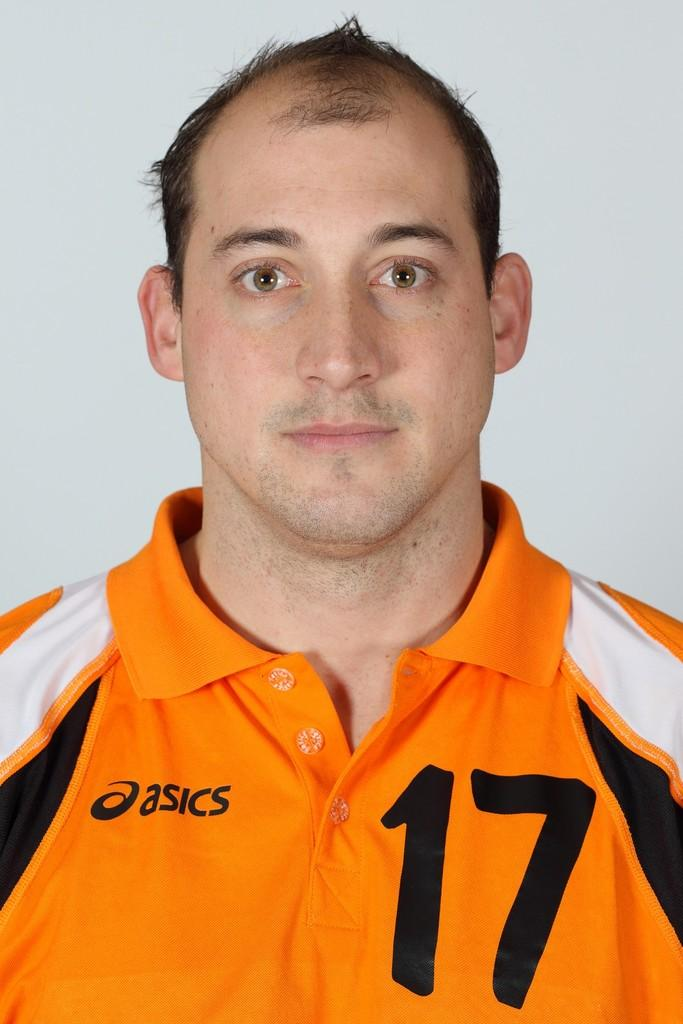<image>
Create a compact narrative representing the image presented. A man in an orange shirt with the asics brand and the number 17. 